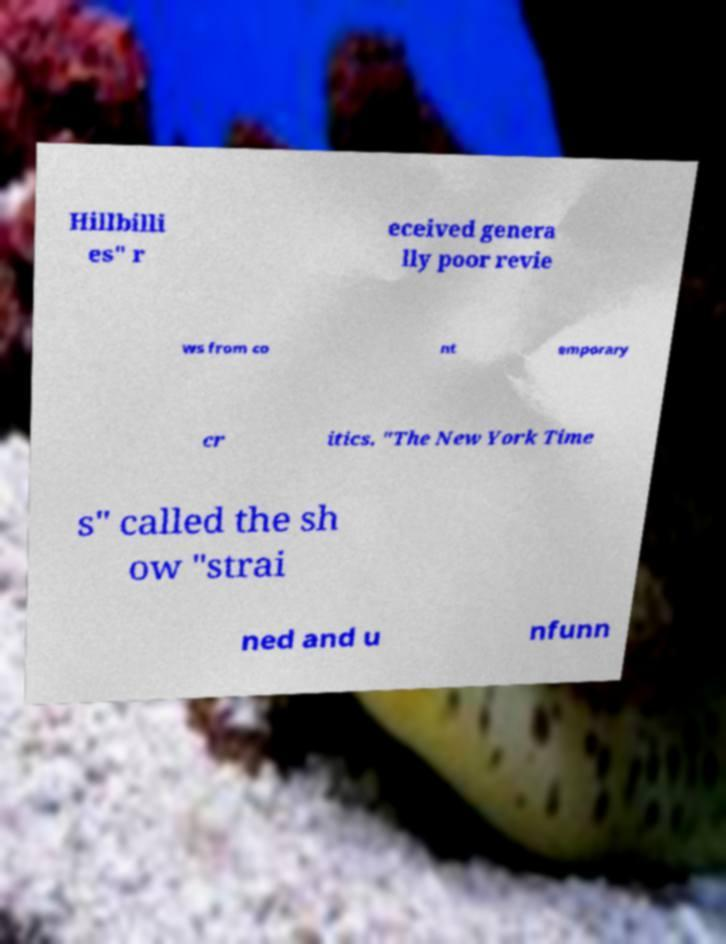For documentation purposes, I need the text within this image transcribed. Could you provide that? Hillbilli es" r eceived genera lly poor revie ws from co nt emporary cr itics. "The New York Time s" called the sh ow "strai ned and u nfunn 